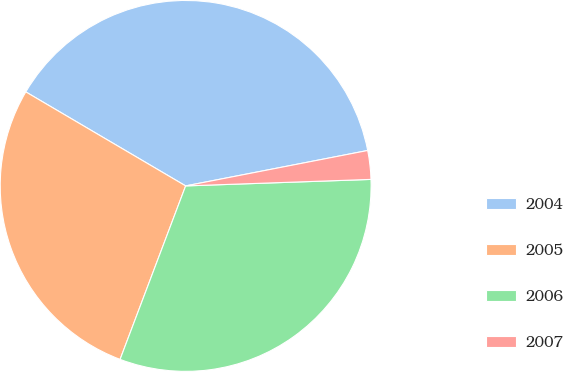<chart> <loc_0><loc_0><loc_500><loc_500><pie_chart><fcel>2004<fcel>2005<fcel>2006<fcel>2007<nl><fcel>38.48%<fcel>27.71%<fcel>31.31%<fcel>2.5%<nl></chart> 